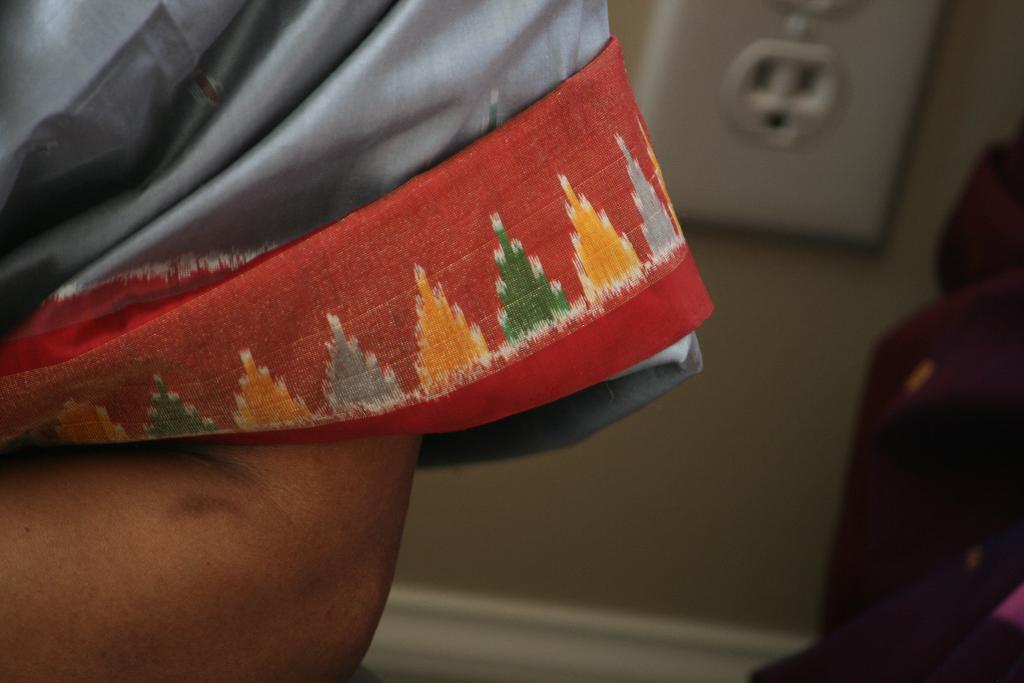What part of a person can be seen in the image? There is a person's hand in the image. What is the person's hand touching or holding in the image? There is a cloth in the image. What can be seen in the background of the image? There is a wall and objects in the background of the image. What type of apple is being used to clean the wall in the image? There is no apple present in the image, and the cloth is not being used to clean the wall. 